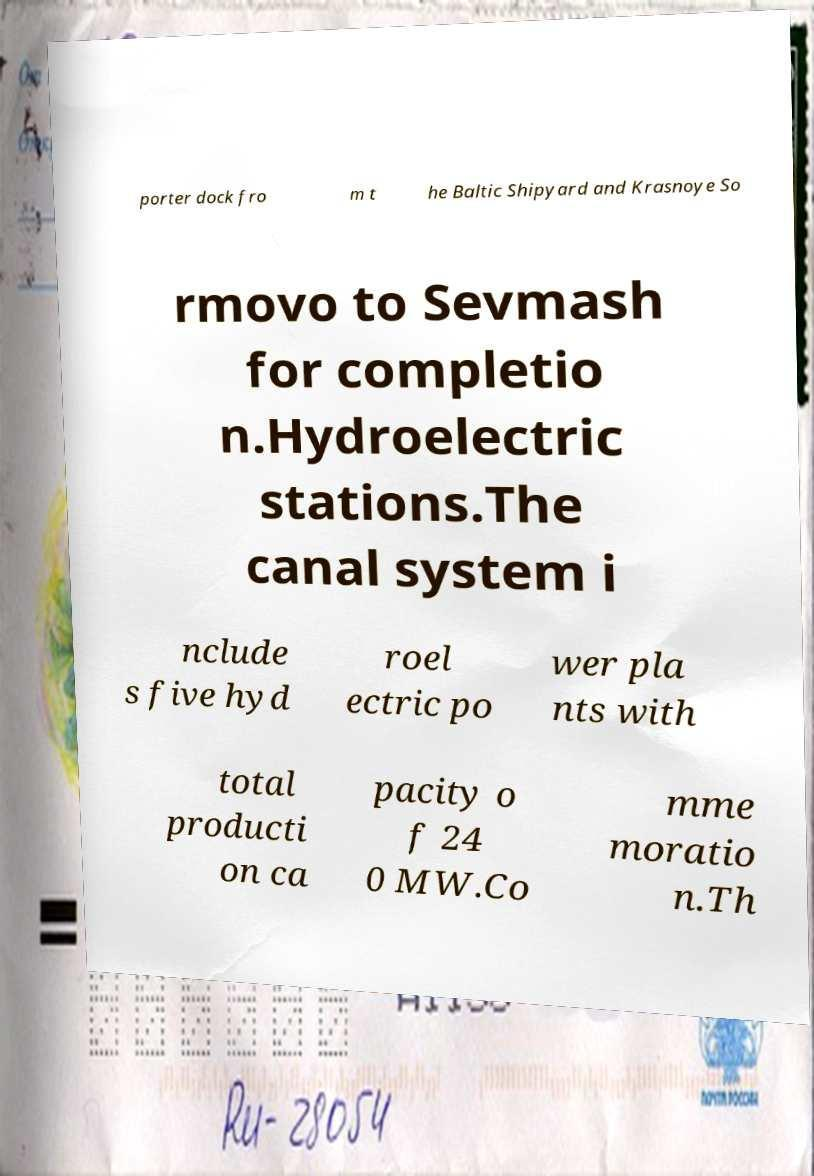What messages or text are displayed in this image? I need them in a readable, typed format. porter dock fro m t he Baltic Shipyard and Krasnoye So rmovo to Sevmash for completio n.Hydroelectric stations.The canal system i nclude s five hyd roel ectric po wer pla nts with total producti on ca pacity o f 24 0 MW.Co mme moratio n.Th 